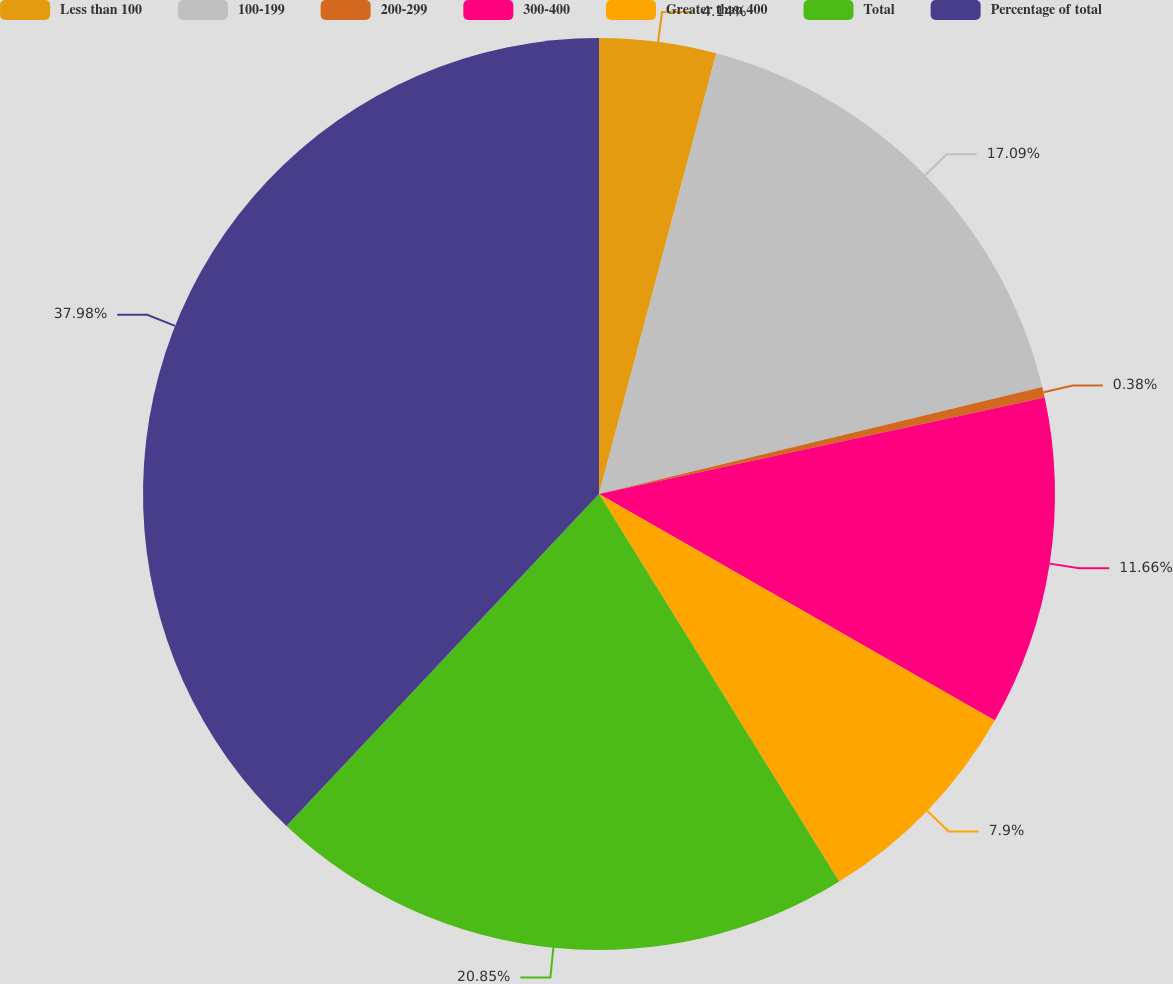Convert chart. <chart><loc_0><loc_0><loc_500><loc_500><pie_chart><fcel>Less than 100<fcel>100-199<fcel>200-299<fcel>300-400<fcel>Greater than 400<fcel>Total<fcel>Percentage of total<nl><fcel>4.14%<fcel>17.09%<fcel>0.38%<fcel>11.66%<fcel>7.9%<fcel>20.85%<fcel>37.98%<nl></chart> 